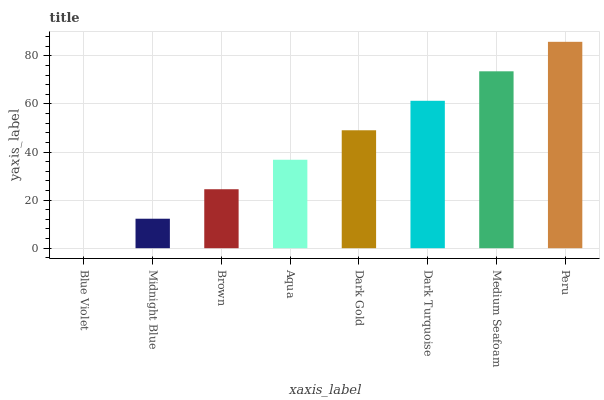Is Midnight Blue the minimum?
Answer yes or no. No. Is Midnight Blue the maximum?
Answer yes or no. No. Is Midnight Blue greater than Blue Violet?
Answer yes or no. Yes. Is Blue Violet less than Midnight Blue?
Answer yes or no. Yes. Is Blue Violet greater than Midnight Blue?
Answer yes or no. No. Is Midnight Blue less than Blue Violet?
Answer yes or no. No. Is Dark Gold the high median?
Answer yes or no. Yes. Is Aqua the low median?
Answer yes or no. Yes. Is Midnight Blue the high median?
Answer yes or no. No. Is Dark Gold the low median?
Answer yes or no. No. 